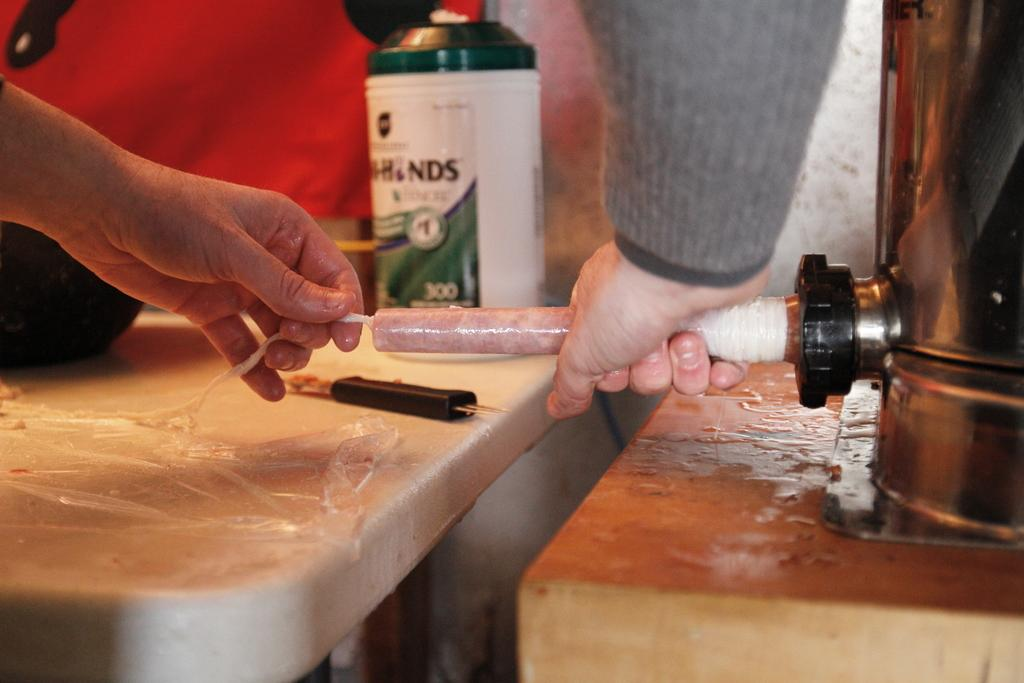Provide a one-sentence caption for the provided image. a person putting a tube up to a machines with NDS in the back. 